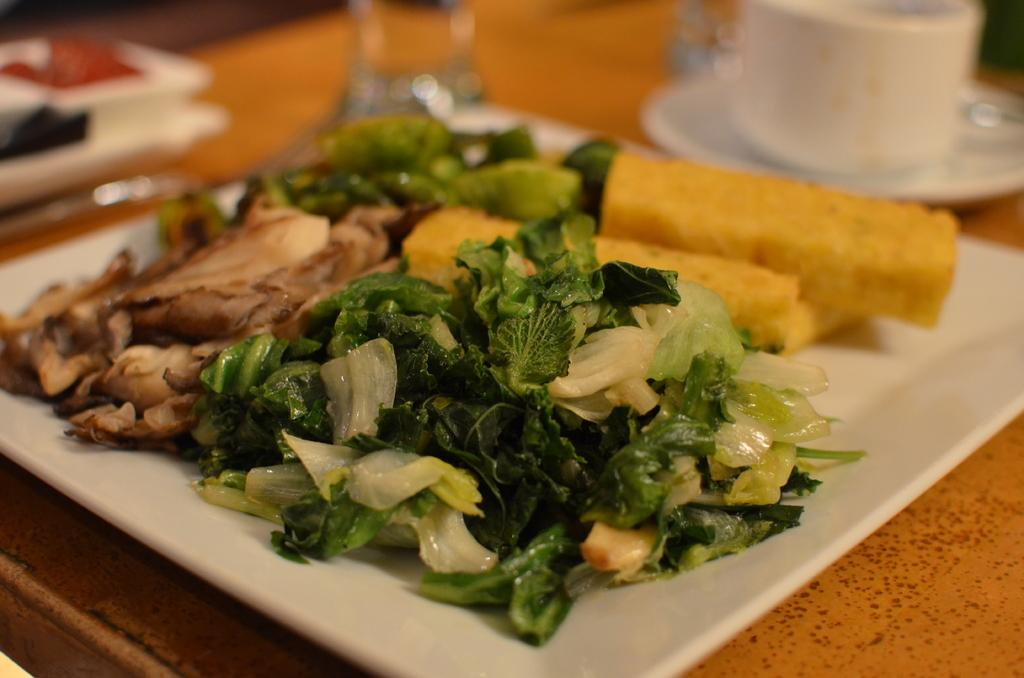What is the main focus of the image? The main focus of the image is the platters containing food items in the center. Can you describe any other items related to serving or consuming food in the image? Yes, there is a cup with a saucer in the image. What else can be seen on the table in the image? There are other items placed on the top of the table in the image. What legal advice is the lawyer providing in the image? There is no lawyer or any legal advice present in the image; it focuses on food items and related items. 